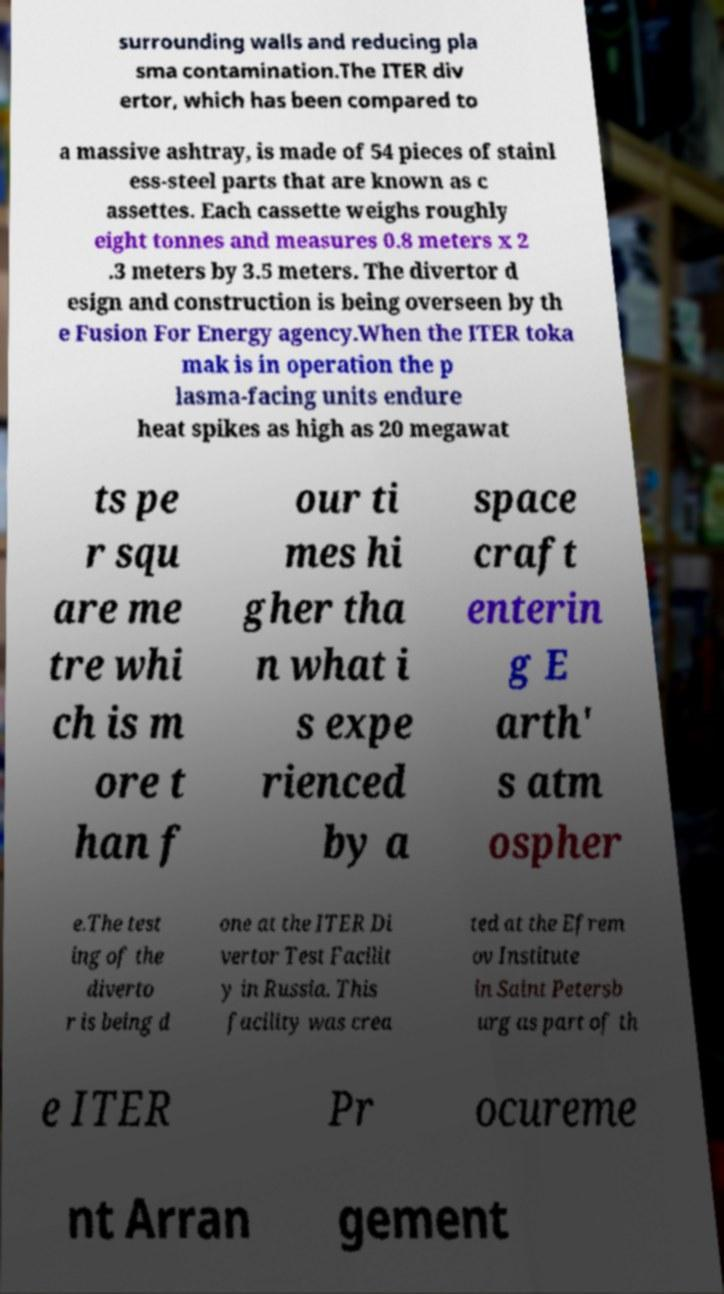Could you assist in decoding the text presented in this image and type it out clearly? surrounding walls and reducing pla sma contamination.The ITER div ertor, which has been compared to a massive ashtray, is made of 54 pieces of stainl ess-steel parts that are known as c assettes. Each cassette weighs roughly eight tonnes and measures 0.8 meters x 2 .3 meters by 3.5 meters. The divertor d esign and construction is being overseen by th e Fusion For Energy agency.When the ITER toka mak is in operation the p lasma-facing units endure heat spikes as high as 20 megawat ts pe r squ are me tre whi ch is m ore t han f our ti mes hi gher tha n what i s expe rienced by a space craft enterin g E arth' s atm ospher e.The test ing of the diverto r is being d one at the ITER Di vertor Test Facilit y in Russia. This facility was crea ted at the Efrem ov Institute in Saint Petersb urg as part of th e ITER Pr ocureme nt Arran gement 